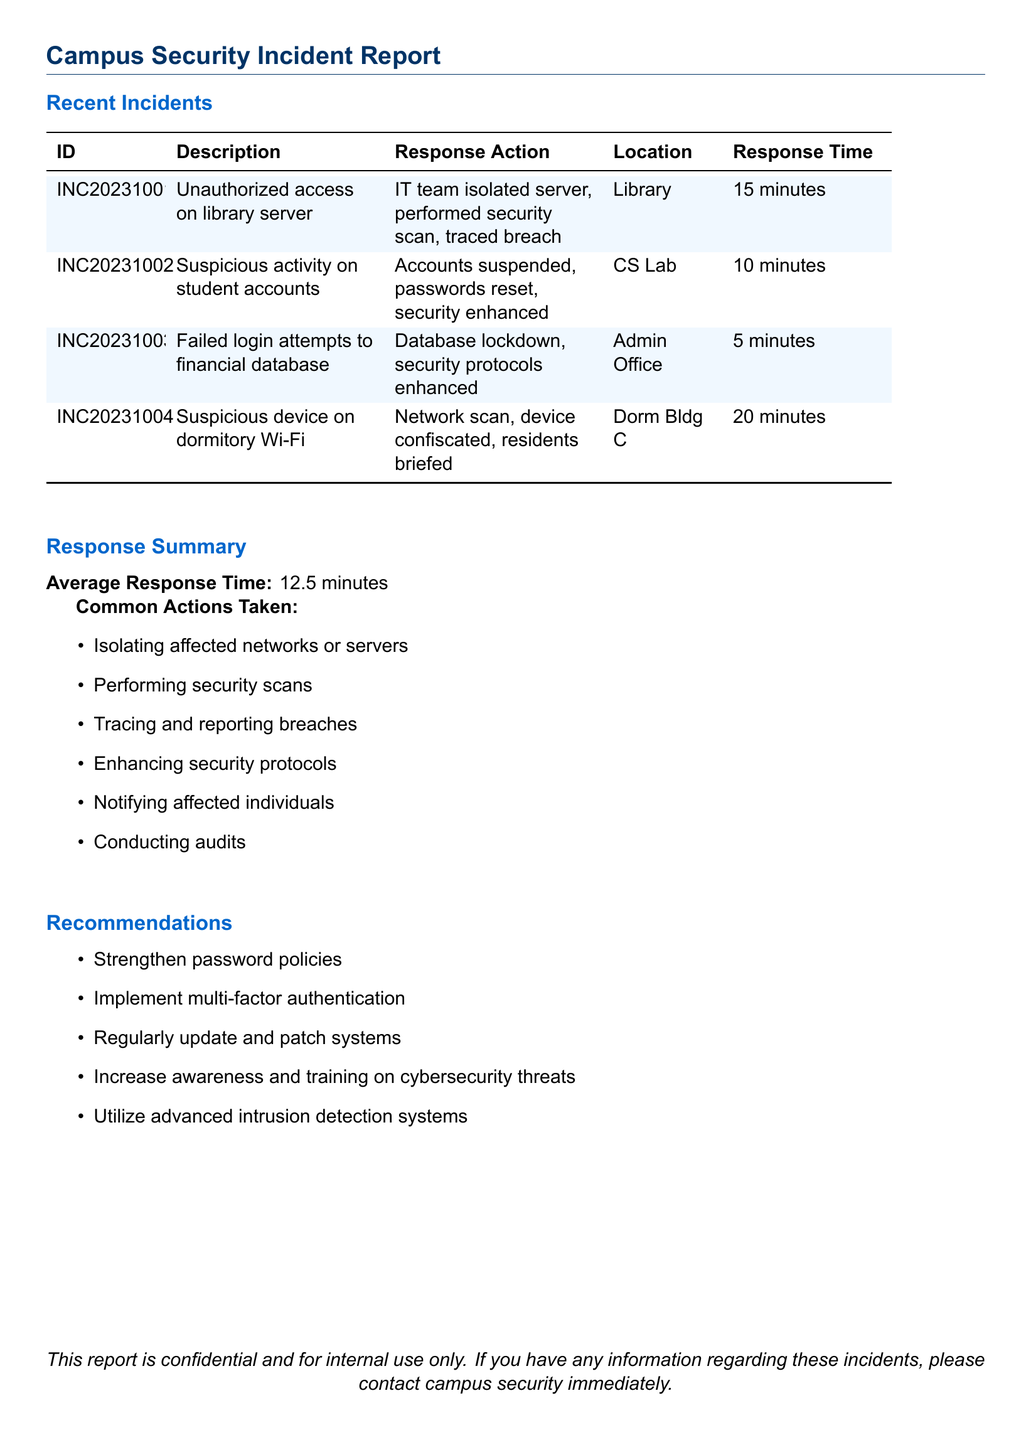What is the ID of the first incident? The ID of the first incident can be found in the Recent Incidents table under the ID column.
Answer: INC20231001 What was the response action for the suspicious device on dormitory Wi-Fi? The response action is detailed in the Recent Incidents table.
Answer: Network scan, device confiscated, residents briefed What is the average response time for incidents? The average response time is calculated from the response times of the incidents listed.
Answer: 12.5 minutes Which location had the quickest response time? The quickest response time can be found by comparing the times in the Recent Incidents table.
Answer: Admin Office What is one common action taken during security incidents? Common actions are listed in the Response Summary section of the document.
Answer: Isolating affected networks or servers How many total incidents are reported in the document? The total number of incidents can be counted from the Recent Incidents table.
Answer: 4 What is the last recommended cybersecurity measure? The recommendations are listed; the last one can be identified easily.
Answer: Utilize advanced intrusion detection systems What type of report is this document categorized as? The document type is specified in the title section.
Answer: Campus Security Incident Report 